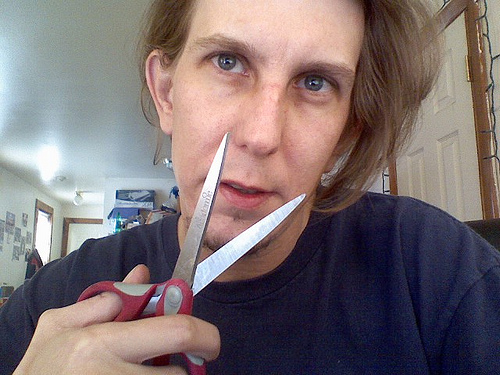What activity is the person engaged in? The person appears to be holding a pair of scissors near their nose, perhaps mimicking a mustache or preparing to cut something close to their face. It is not a recommended or safe use of scissors, and proper caution should be exercised to avoid any accidents. 